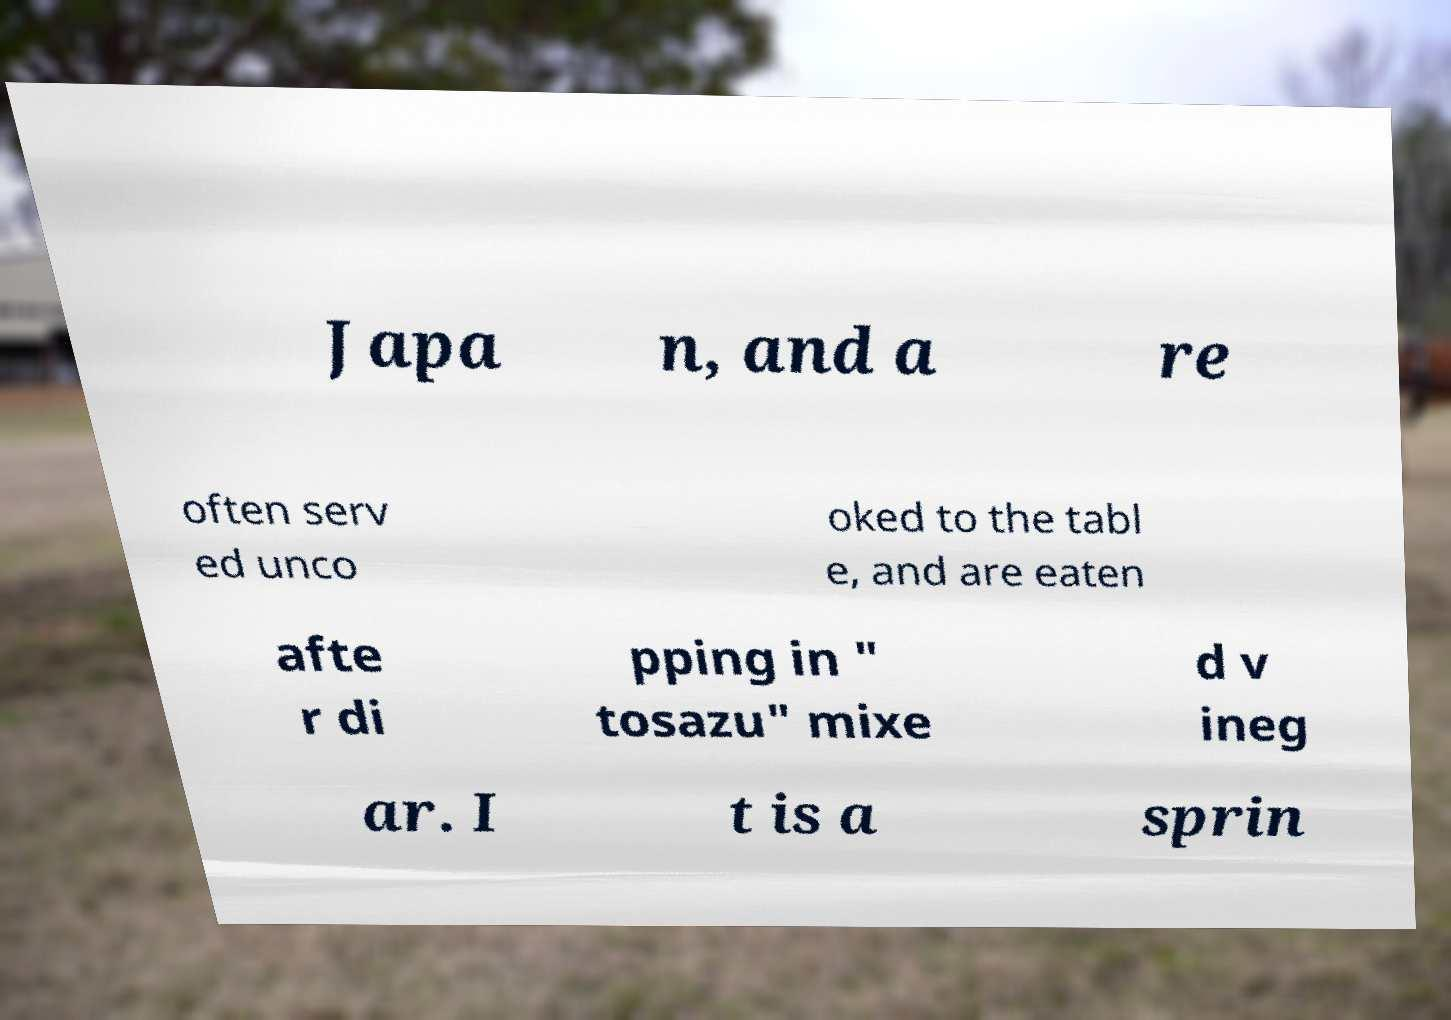There's text embedded in this image that I need extracted. Can you transcribe it verbatim? Japa n, and a re often serv ed unco oked to the tabl e, and are eaten afte r di pping in " tosazu" mixe d v ineg ar. I t is a sprin 